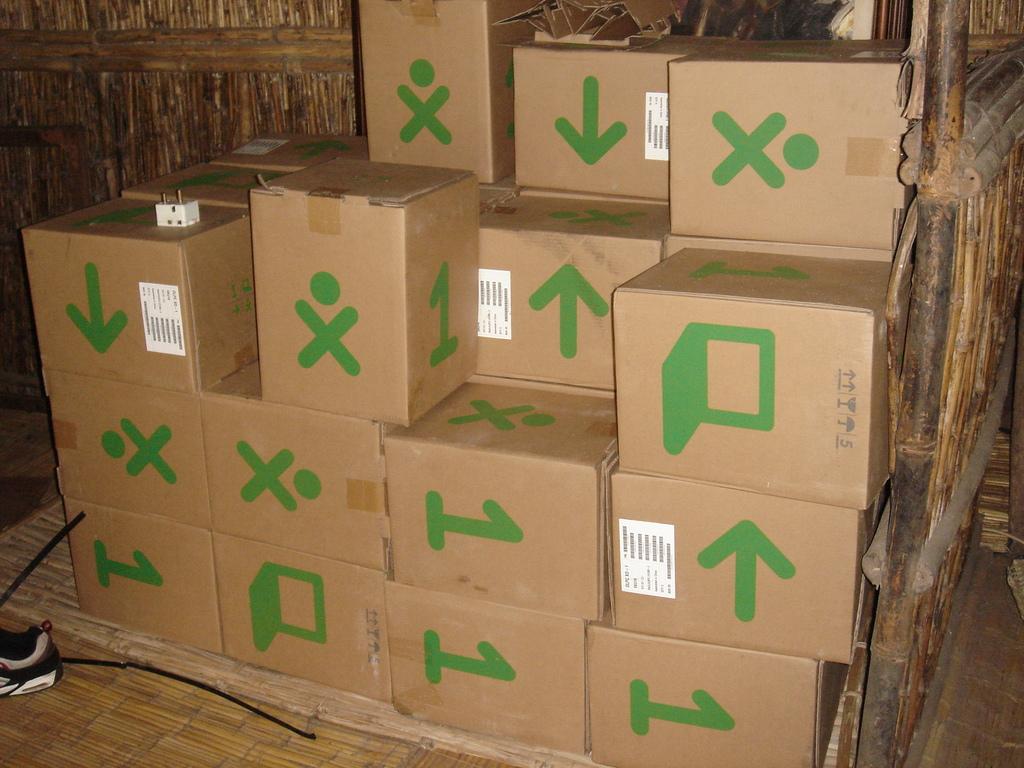What is the number shown on the boxes?
Ensure brevity in your answer.  1. 